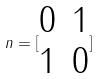<formula> <loc_0><loc_0><loc_500><loc_500>n = [ \begin{matrix} 0 & 1 \\ 1 & 0 \end{matrix} ]</formula> 